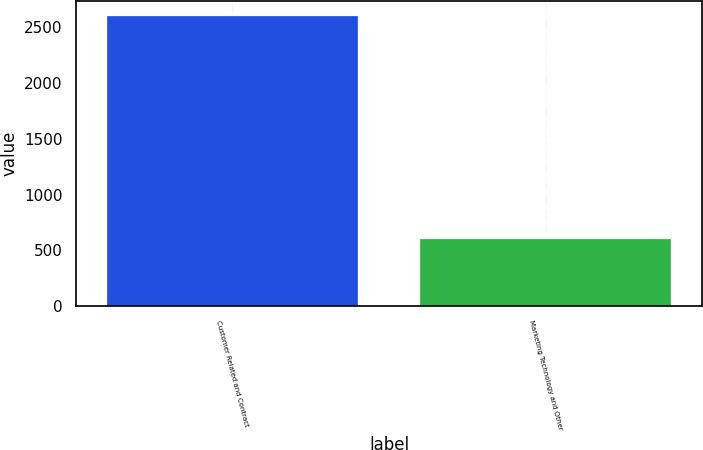Convert chart. <chart><loc_0><loc_0><loc_500><loc_500><bar_chart><fcel>Customer Related and Contract<fcel>Marketing Technology and Other<nl><fcel>2605<fcel>606<nl></chart> 